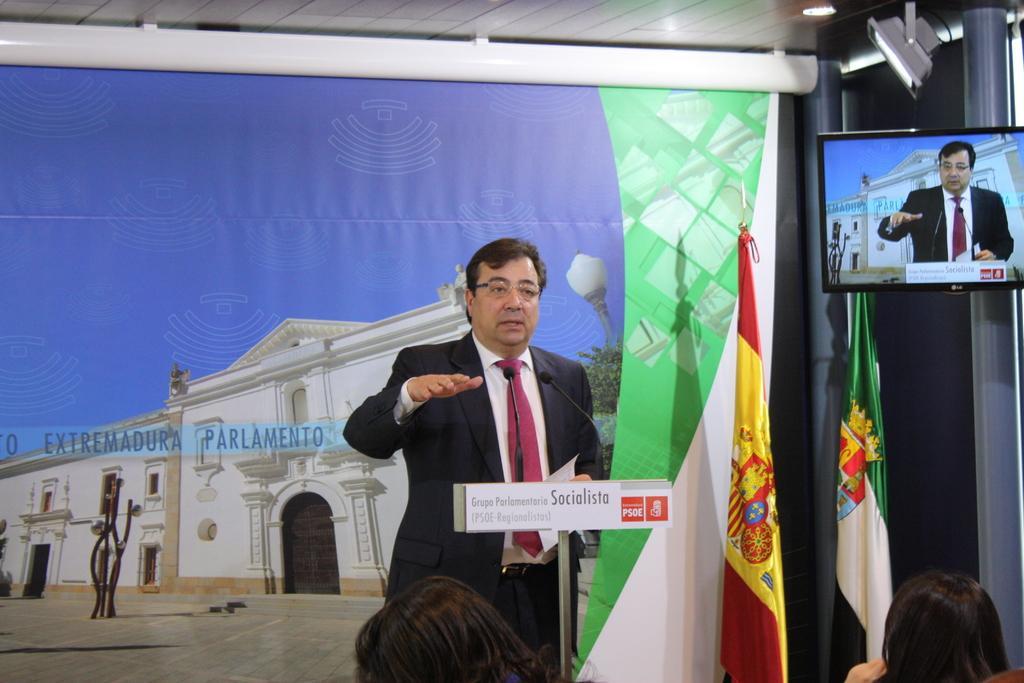Describe this image in one or two sentences. In this picture there is a man who is wearing suit and spectacle. He is standing near to the speech desk. On the speech desk we can see mic and paper. Behind him we can see the banner. On the right there are two flags near to the television. At the bottom there are two women were sitting on the chair. In the top right corner there is a focus light. In the banner we can see the building, trees, street light and sky. 